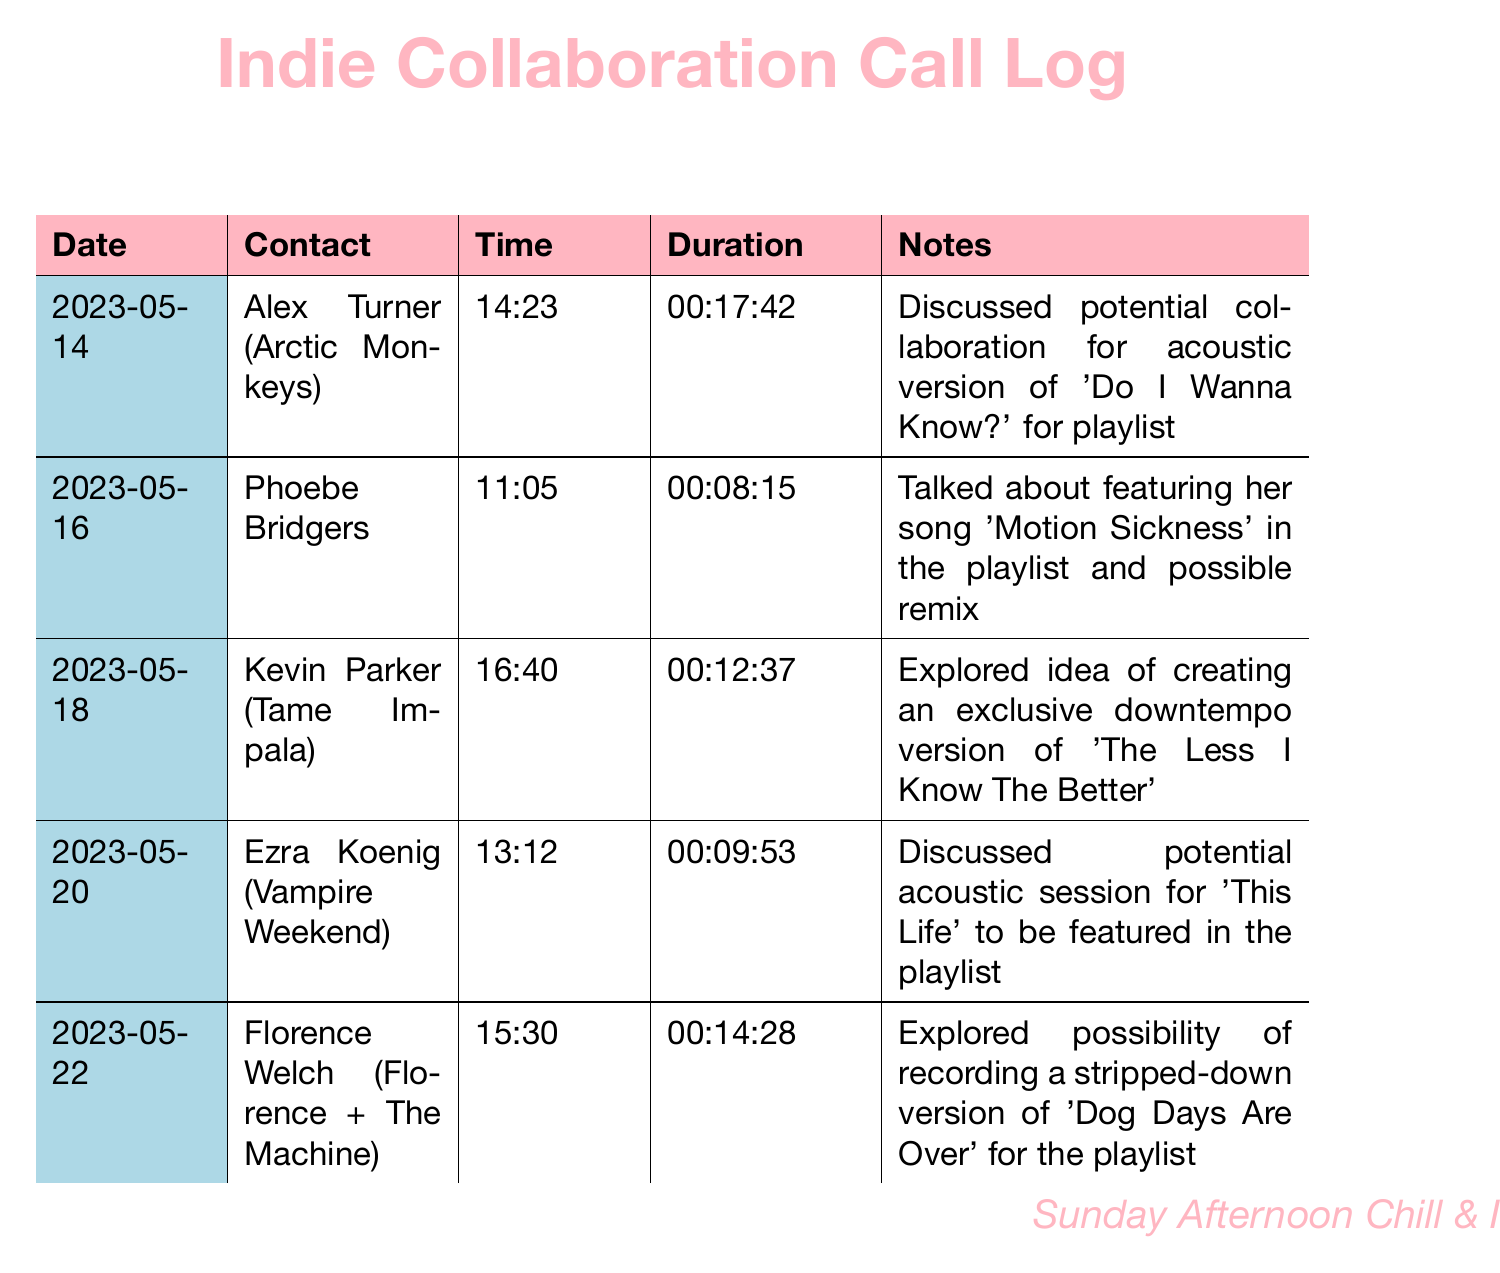What is the date of the call with Alex Turner? The date of the call with Alex Turner is mentioned in the table under the Date column.
Answer: 2023-05-14 How long was the conversation with Phoebe Bridgers? The duration of the conversation with Phoebe Bridgers is listed in the Duration column of the call log.
Answer: 00:08:15 Who discussed a collaboration on 'Dog Days Are Over'? The contact who discussed the collaboration is listed in the Contact column of the call log.
Answer: Florence Welch What was the main idea discussed with Kevin Parker? The main idea discussed with Kevin Parker involves creating an exclusive version of a song, which is noted in the Notes column.
Answer: Downtempo version of 'The Less I Know The Better' How many calls are recorded in the log? The total number of calls can be counted by the entries in the table.
Answer: 5 What time did the call with Ezra Koenig take place? The time of the call is indicated in the Time column associated with Ezra Koenig.
Answer: 13:12 Which band member's song was talked about for a possible remix? The specific band member discussed for a possible remix is found in the Notes column for that entry.
Answer: Phoebe Bridgers What is the purpose of these calls? The purpose can be inferred from the notes across all entries, emphasizing collaborations.
Answer: Collaborations 